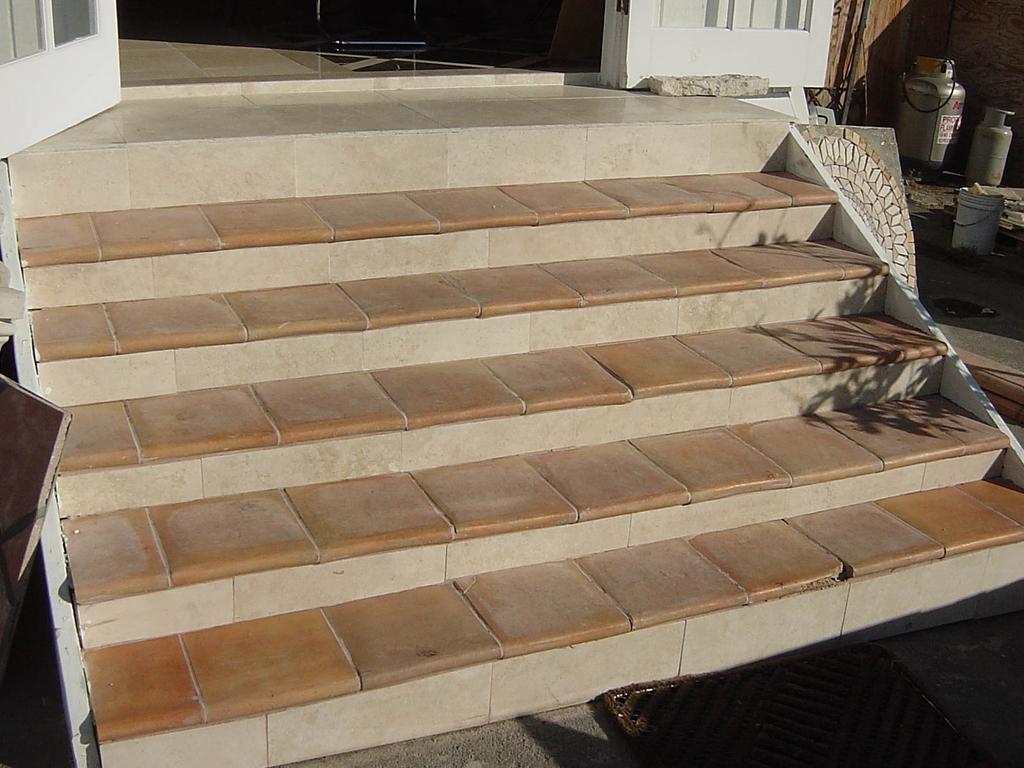Please provide a concise description of this image. At the bottom of the picture, we see the doormat. Beside that, we see the staircase. In the left top, we see a white door. On the right side, we see the cans and a white bucket. Beside that, we see a brown wall and beside that, we see a white door and a stone. 